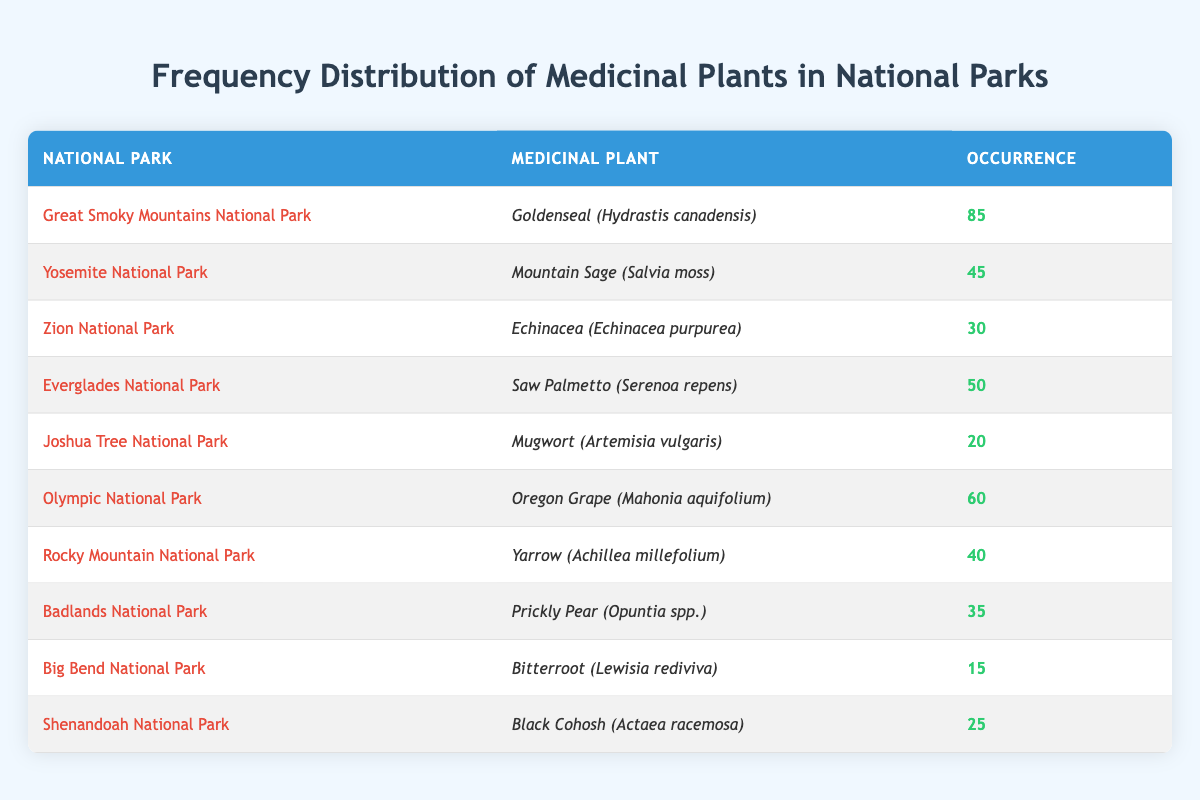What is the occurrence of Goldenseal in Great Smoky Mountains National Park? The table explicitly states that Goldenseal (Hydrastis canadensis) has an occurrence of 85 in the Great Smoky Mountains National Park.
Answer: 85 Which medicinal plant has the highest occurrence in the table? According to the table, Goldenseal (Hydrastis canadensis) has the highest occurrence with a value of 85.
Answer: Goldenseal (Hydrastis canadensis) Is the occurrence of Echinacea in Zion National Park greater than 25? The table shows that the occurrence of Echinacea (Echinacea purpurea) is 30, which is indeed greater than 25.
Answer: Yes What is the total occurrence of medicinal plants listed in the table? By adding all occurrences from the table: 85 + 45 + 30 + 50 + 20 + 60 + 40 + 35 + 15 + 25 = 435, the total occurrence of all medicinal plants is 435.
Answer: 435 Which national park has the lowest occurrence of medicinal plants, and what is that occurrence? The lowest occurrence is found in Big Bend National Park with the occurrence of 15 for Bitterroot (Lewisia rediviva).
Answer: Big Bend National Park, 15 What is the average occurrence of medicinal plants across the national parks mentioned? To find the average, sum all occurrences (the sum is 435) and divide by the number of rows, which is 10. So, the average occurrence is 435/10 = 43.5.
Answer: 43.5 Are there more occurrences of Saw Palmetto in Everglades National Park than Mountain Sage in Yosemite National Park? Saw Palmetto has an occurrence of 50 while Mountain Sage has 45. Since 50 is greater than 45, the statement is true.
Answer: Yes How many national parks have an occurrence of medicinal plants greater than 40? By examining the occurrences above 40, we find Goldenseal (85), Saw Palmetto (50), Oregon Grape (60), and Mountain Sage (45), leading to a total of 4 national parks.
Answer: 4 Which medicinal plant is found in both Joshua Tree National Park and Shenandoah National Park? By checking the table, it's clear that there are no medicinal plants listed in both Joshua Tree National Park and Shenandoah National Park; they are distinct entries.
Answer: None 